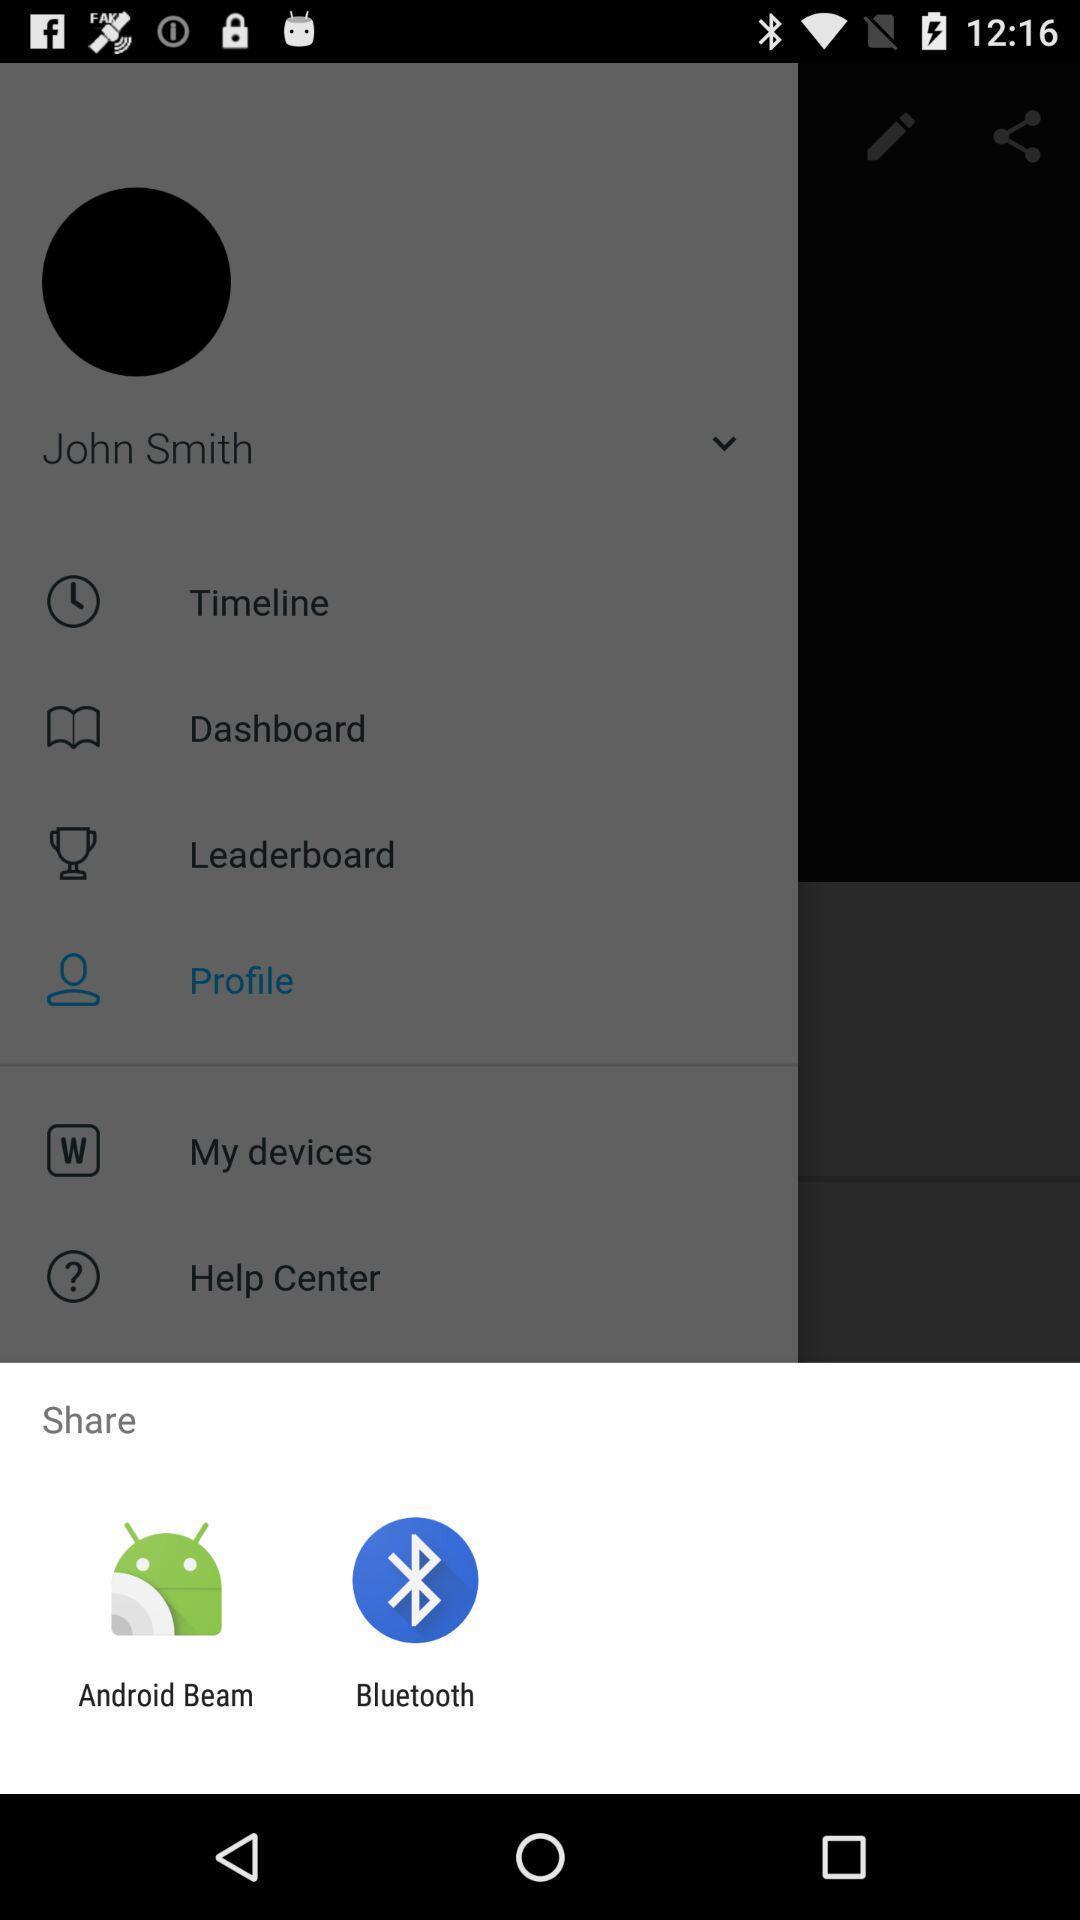Describe the key features of this screenshot. Share options page of a health tracker app. 